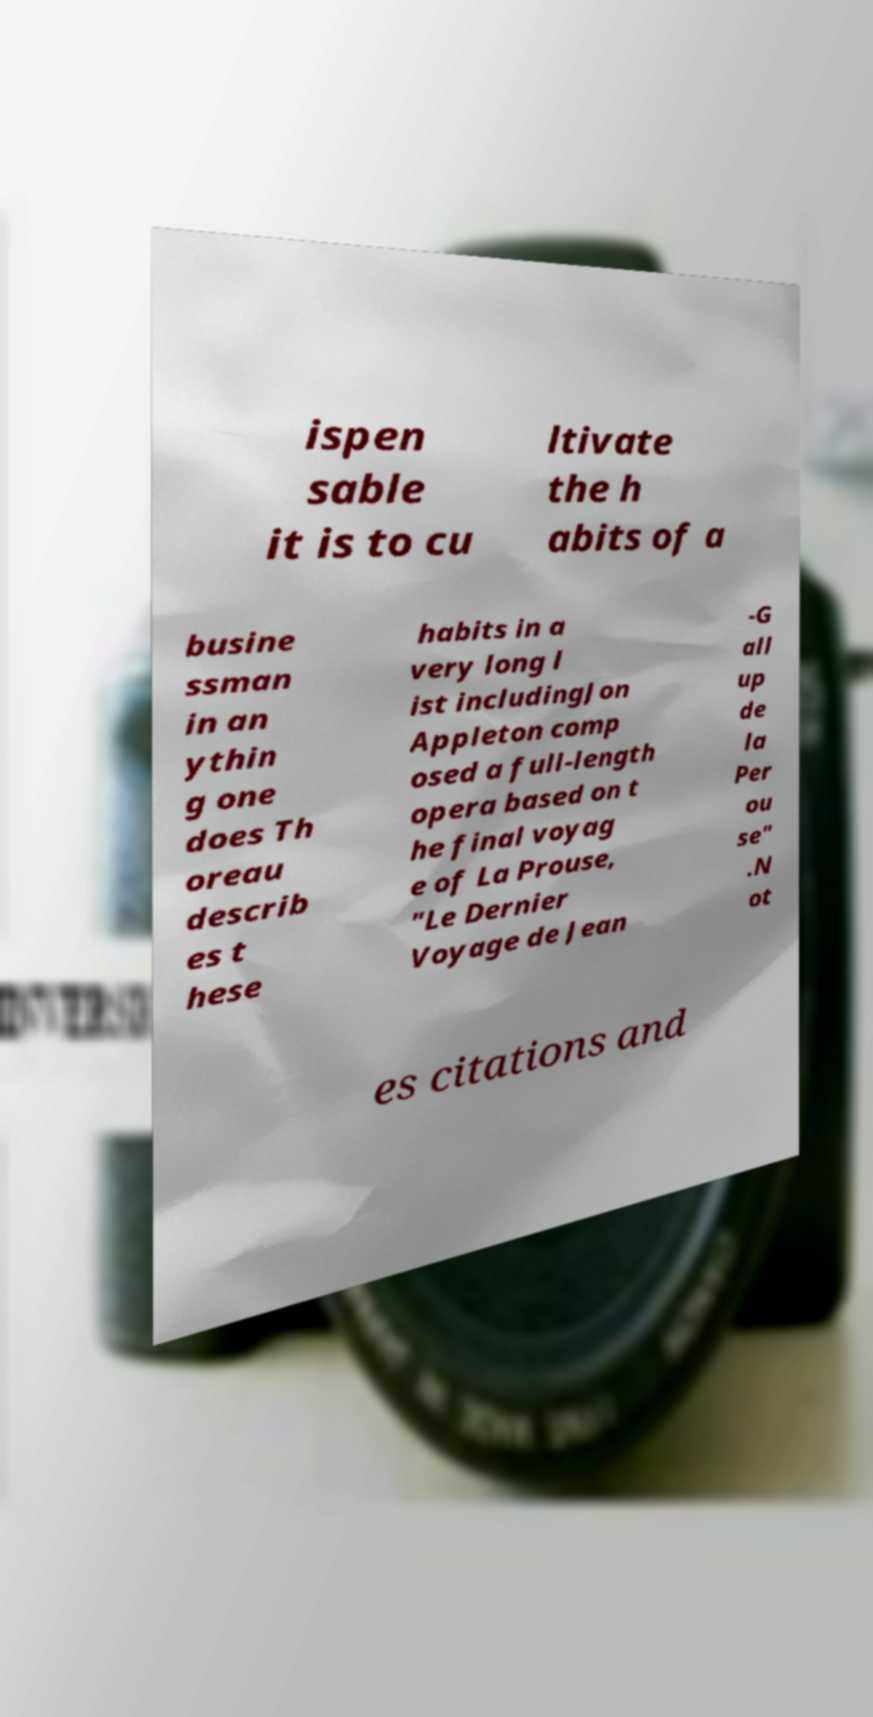I need the written content from this picture converted into text. Can you do that? ispen sable it is to cu ltivate the h abits of a busine ssman in an ythin g one does Th oreau describ es t hese habits in a very long l ist includingJon Appleton comp osed a full-length opera based on t he final voyag e of La Prouse, "Le Dernier Voyage de Jean -G all up de la Per ou se" .N ot es citations and 